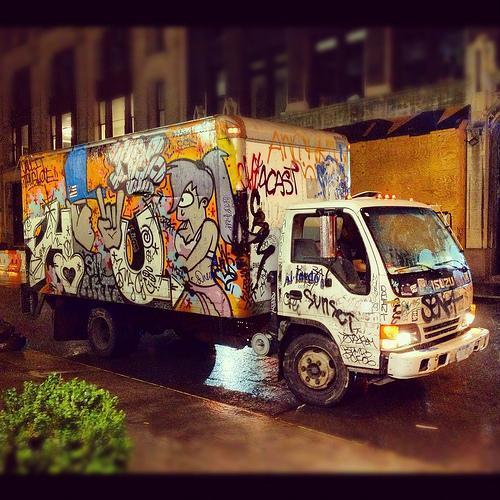How many trucks on the street?
Give a very brief answer. 1. 